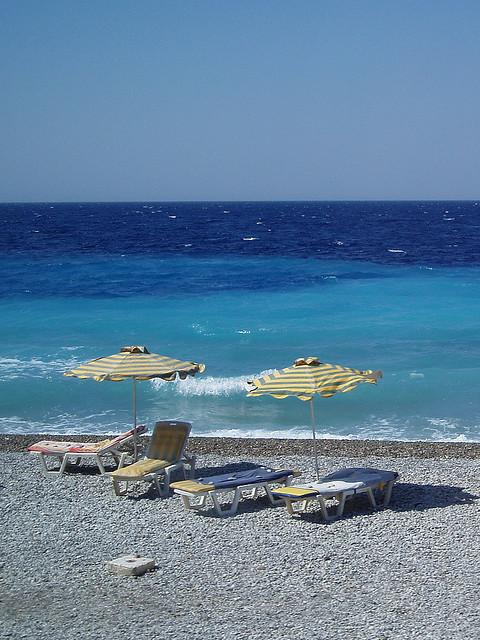How many umbrellas are there?
Concise answer only. 2. What is sitting on the sand?
Give a very brief answer. Lounge chairs. How calm is the water?
Concise answer only. Calm. What sticks out the water?
Short answer required. Waves. What color is the chair?
Quick response, please. Yellow. Are there people in the picture?
Keep it brief. No. 